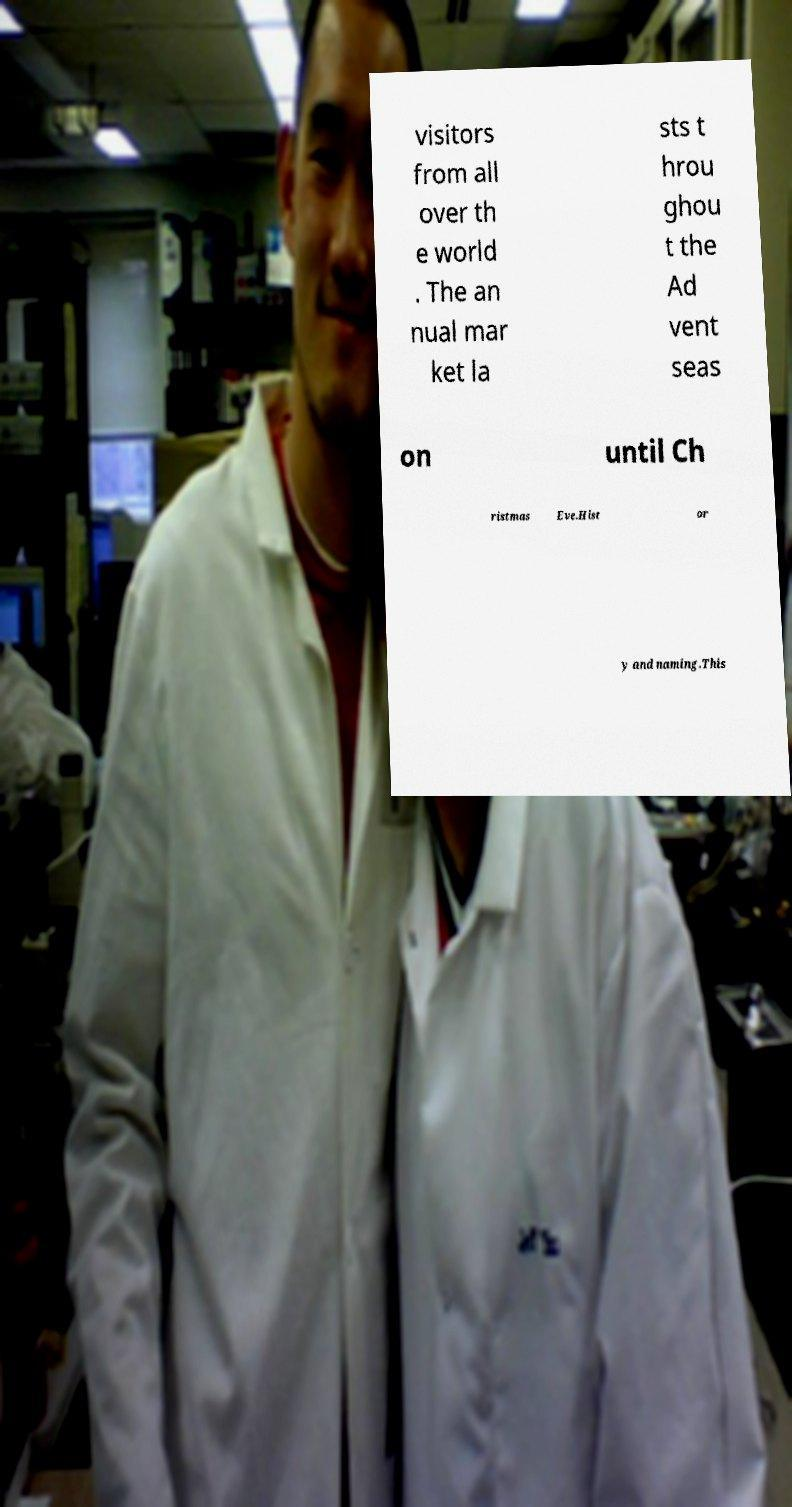I need the written content from this picture converted into text. Can you do that? visitors from all over th e world . The an nual mar ket la sts t hrou ghou t the Ad vent seas on until Ch ristmas Eve.Hist or y and naming.This 